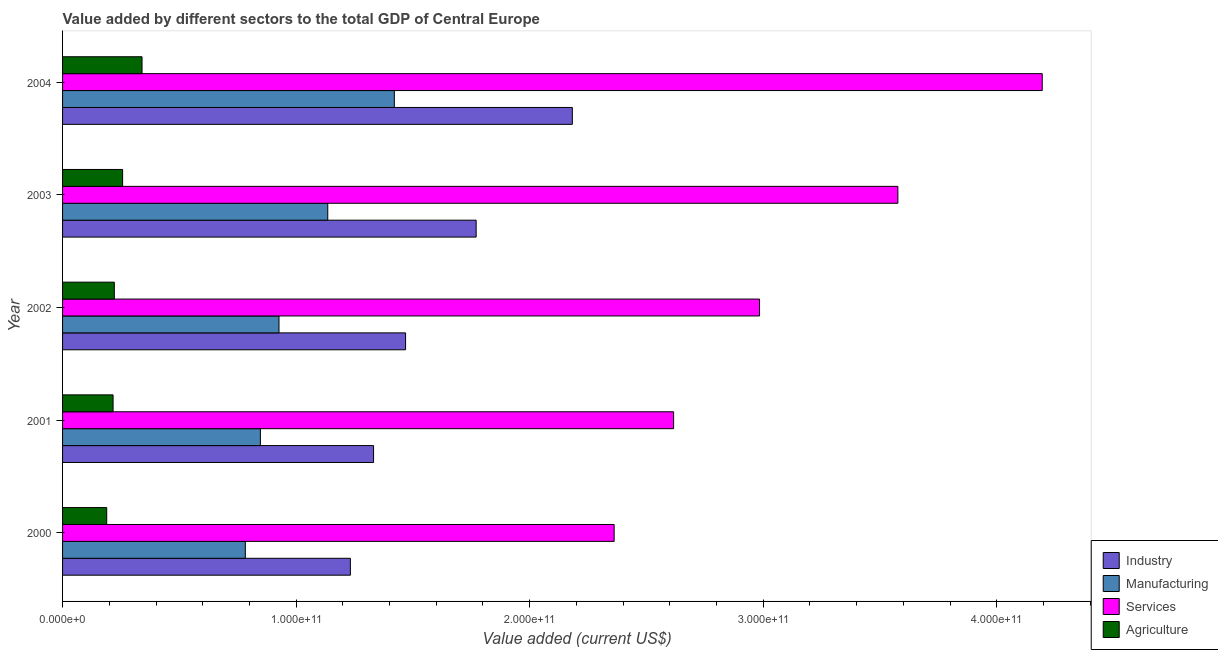How many different coloured bars are there?
Provide a short and direct response. 4. How many groups of bars are there?
Your response must be concise. 5. Are the number of bars on each tick of the Y-axis equal?
Keep it short and to the point. Yes. How many bars are there on the 3rd tick from the top?
Make the answer very short. 4. How many bars are there on the 3rd tick from the bottom?
Provide a succinct answer. 4. What is the label of the 4th group of bars from the top?
Offer a very short reply. 2001. What is the value added by manufacturing sector in 2002?
Provide a short and direct response. 9.27e+1. Across all years, what is the maximum value added by services sector?
Your response must be concise. 4.19e+11. Across all years, what is the minimum value added by services sector?
Your answer should be compact. 2.36e+11. In which year was the value added by industrial sector maximum?
Provide a succinct answer. 2004. In which year was the value added by manufacturing sector minimum?
Give a very brief answer. 2000. What is the total value added by agricultural sector in the graph?
Offer a terse response. 1.22e+11. What is the difference between the value added by industrial sector in 2000 and that in 2002?
Offer a terse response. -2.36e+1. What is the difference between the value added by industrial sector in 2004 and the value added by agricultural sector in 2002?
Your answer should be very brief. 1.96e+11. What is the average value added by services sector per year?
Offer a very short reply. 3.15e+11. In the year 2001, what is the difference between the value added by industrial sector and value added by agricultural sector?
Give a very brief answer. 1.12e+11. What is the ratio of the value added by agricultural sector in 2000 to that in 2001?
Offer a very short reply. 0.87. Is the difference between the value added by services sector in 2003 and 2004 greater than the difference between the value added by industrial sector in 2003 and 2004?
Offer a very short reply. No. What is the difference between the highest and the second highest value added by services sector?
Your response must be concise. 6.18e+1. What is the difference between the highest and the lowest value added by services sector?
Give a very brief answer. 1.83e+11. In how many years, is the value added by agricultural sector greater than the average value added by agricultural sector taken over all years?
Your answer should be compact. 2. Is it the case that in every year, the sum of the value added by agricultural sector and value added by services sector is greater than the sum of value added by industrial sector and value added by manufacturing sector?
Your answer should be very brief. No. What does the 1st bar from the top in 2002 represents?
Offer a very short reply. Agriculture. What does the 4th bar from the bottom in 2002 represents?
Make the answer very short. Agriculture. Is it the case that in every year, the sum of the value added by industrial sector and value added by manufacturing sector is greater than the value added by services sector?
Keep it short and to the point. No. How many bars are there?
Offer a terse response. 20. Are all the bars in the graph horizontal?
Your answer should be very brief. Yes. How many years are there in the graph?
Ensure brevity in your answer.  5. What is the difference between two consecutive major ticks on the X-axis?
Provide a short and direct response. 1.00e+11. Are the values on the major ticks of X-axis written in scientific E-notation?
Offer a terse response. Yes. Where does the legend appear in the graph?
Your answer should be very brief. Bottom right. How many legend labels are there?
Ensure brevity in your answer.  4. How are the legend labels stacked?
Offer a terse response. Vertical. What is the title of the graph?
Offer a terse response. Value added by different sectors to the total GDP of Central Europe. Does "Miscellaneous expenses" appear as one of the legend labels in the graph?
Ensure brevity in your answer.  No. What is the label or title of the X-axis?
Your response must be concise. Value added (current US$). What is the label or title of the Y-axis?
Offer a very short reply. Year. What is the Value added (current US$) in Industry in 2000?
Provide a succinct answer. 1.23e+11. What is the Value added (current US$) in Manufacturing in 2000?
Your answer should be very brief. 7.82e+1. What is the Value added (current US$) in Services in 2000?
Keep it short and to the point. 2.36e+11. What is the Value added (current US$) of Agriculture in 2000?
Your answer should be very brief. 1.89e+1. What is the Value added (current US$) of Industry in 2001?
Give a very brief answer. 1.33e+11. What is the Value added (current US$) in Manufacturing in 2001?
Ensure brevity in your answer.  8.47e+1. What is the Value added (current US$) of Services in 2001?
Your answer should be compact. 2.62e+11. What is the Value added (current US$) of Agriculture in 2001?
Offer a terse response. 2.16e+1. What is the Value added (current US$) in Industry in 2002?
Provide a succinct answer. 1.47e+11. What is the Value added (current US$) in Manufacturing in 2002?
Keep it short and to the point. 9.27e+1. What is the Value added (current US$) in Services in 2002?
Your answer should be very brief. 2.98e+11. What is the Value added (current US$) of Agriculture in 2002?
Your response must be concise. 2.22e+1. What is the Value added (current US$) in Industry in 2003?
Your answer should be compact. 1.77e+11. What is the Value added (current US$) of Manufacturing in 2003?
Keep it short and to the point. 1.14e+11. What is the Value added (current US$) in Services in 2003?
Keep it short and to the point. 3.58e+11. What is the Value added (current US$) of Agriculture in 2003?
Your answer should be compact. 2.57e+1. What is the Value added (current US$) in Industry in 2004?
Give a very brief answer. 2.18e+11. What is the Value added (current US$) in Manufacturing in 2004?
Your response must be concise. 1.42e+11. What is the Value added (current US$) of Services in 2004?
Provide a short and direct response. 4.19e+11. What is the Value added (current US$) of Agriculture in 2004?
Provide a short and direct response. 3.40e+1. Across all years, what is the maximum Value added (current US$) in Industry?
Ensure brevity in your answer.  2.18e+11. Across all years, what is the maximum Value added (current US$) in Manufacturing?
Keep it short and to the point. 1.42e+11. Across all years, what is the maximum Value added (current US$) in Services?
Your answer should be compact. 4.19e+11. Across all years, what is the maximum Value added (current US$) in Agriculture?
Give a very brief answer. 3.40e+1. Across all years, what is the minimum Value added (current US$) of Industry?
Ensure brevity in your answer.  1.23e+11. Across all years, what is the minimum Value added (current US$) of Manufacturing?
Ensure brevity in your answer.  7.82e+1. Across all years, what is the minimum Value added (current US$) in Services?
Ensure brevity in your answer.  2.36e+11. Across all years, what is the minimum Value added (current US$) in Agriculture?
Make the answer very short. 1.89e+1. What is the total Value added (current US$) in Industry in the graph?
Offer a terse response. 7.99e+11. What is the total Value added (current US$) in Manufacturing in the graph?
Ensure brevity in your answer.  5.11e+11. What is the total Value added (current US$) of Services in the graph?
Make the answer very short. 1.57e+12. What is the total Value added (current US$) of Agriculture in the graph?
Give a very brief answer. 1.22e+11. What is the difference between the Value added (current US$) of Industry in 2000 and that in 2001?
Your answer should be very brief. -9.93e+09. What is the difference between the Value added (current US$) in Manufacturing in 2000 and that in 2001?
Make the answer very short. -6.45e+09. What is the difference between the Value added (current US$) of Services in 2000 and that in 2001?
Your response must be concise. -2.55e+1. What is the difference between the Value added (current US$) of Agriculture in 2000 and that in 2001?
Make the answer very short. -2.73e+09. What is the difference between the Value added (current US$) of Industry in 2000 and that in 2002?
Your response must be concise. -2.36e+1. What is the difference between the Value added (current US$) in Manufacturing in 2000 and that in 2002?
Your response must be concise. -1.44e+1. What is the difference between the Value added (current US$) of Services in 2000 and that in 2002?
Ensure brevity in your answer.  -6.22e+1. What is the difference between the Value added (current US$) of Agriculture in 2000 and that in 2002?
Your response must be concise. -3.26e+09. What is the difference between the Value added (current US$) of Industry in 2000 and that in 2003?
Keep it short and to the point. -5.39e+1. What is the difference between the Value added (current US$) in Manufacturing in 2000 and that in 2003?
Your answer should be very brief. -3.53e+1. What is the difference between the Value added (current US$) in Services in 2000 and that in 2003?
Give a very brief answer. -1.21e+11. What is the difference between the Value added (current US$) of Agriculture in 2000 and that in 2003?
Your response must be concise. -6.80e+09. What is the difference between the Value added (current US$) in Industry in 2000 and that in 2004?
Your answer should be very brief. -9.50e+1. What is the difference between the Value added (current US$) in Manufacturing in 2000 and that in 2004?
Ensure brevity in your answer.  -6.38e+1. What is the difference between the Value added (current US$) in Services in 2000 and that in 2004?
Offer a very short reply. -1.83e+11. What is the difference between the Value added (current US$) in Agriculture in 2000 and that in 2004?
Your answer should be compact. -1.51e+1. What is the difference between the Value added (current US$) in Industry in 2001 and that in 2002?
Your answer should be compact. -1.37e+1. What is the difference between the Value added (current US$) of Manufacturing in 2001 and that in 2002?
Offer a very short reply. -7.97e+09. What is the difference between the Value added (current US$) of Services in 2001 and that in 2002?
Provide a short and direct response. -3.68e+1. What is the difference between the Value added (current US$) in Agriculture in 2001 and that in 2002?
Offer a terse response. -5.33e+08. What is the difference between the Value added (current US$) of Industry in 2001 and that in 2003?
Ensure brevity in your answer.  -4.39e+1. What is the difference between the Value added (current US$) in Manufacturing in 2001 and that in 2003?
Make the answer very short. -2.88e+1. What is the difference between the Value added (current US$) in Services in 2001 and that in 2003?
Offer a very short reply. -9.60e+1. What is the difference between the Value added (current US$) of Agriculture in 2001 and that in 2003?
Offer a very short reply. -4.08e+09. What is the difference between the Value added (current US$) in Industry in 2001 and that in 2004?
Give a very brief answer. -8.51e+1. What is the difference between the Value added (current US$) of Manufacturing in 2001 and that in 2004?
Give a very brief answer. -5.73e+1. What is the difference between the Value added (current US$) in Services in 2001 and that in 2004?
Your answer should be compact. -1.58e+11. What is the difference between the Value added (current US$) of Agriculture in 2001 and that in 2004?
Make the answer very short. -1.24e+1. What is the difference between the Value added (current US$) in Industry in 2002 and that in 2003?
Make the answer very short. -3.02e+1. What is the difference between the Value added (current US$) of Manufacturing in 2002 and that in 2003?
Your answer should be compact. -2.09e+1. What is the difference between the Value added (current US$) in Services in 2002 and that in 2003?
Keep it short and to the point. -5.92e+1. What is the difference between the Value added (current US$) of Agriculture in 2002 and that in 2003?
Offer a terse response. -3.54e+09. What is the difference between the Value added (current US$) of Industry in 2002 and that in 2004?
Make the answer very short. -7.14e+1. What is the difference between the Value added (current US$) in Manufacturing in 2002 and that in 2004?
Offer a very short reply. -4.94e+1. What is the difference between the Value added (current US$) of Services in 2002 and that in 2004?
Provide a succinct answer. -1.21e+11. What is the difference between the Value added (current US$) of Agriculture in 2002 and that in 2004?
Keep it short and to the point. -1.19e+1. What is the difference between the Value added (current US$) in Industry in 2003 and that in 2004?
Keep it short and to the point. -4.12e+1. What is the difference between the Value added (current US$) of Manufacturing in 2003 and that in 2004?
Make the answer very short. -2.85e+1. What is the difference between the Value added (current US$) of Services in 2003 and that in 2004?
Your response must be concise. -6.18e+1. What is the difference between the Value added (current US$) of Agriculture in 2003 and that in 2004?
Give a very brief answer. -8.32e+09. What is the difference between the Value added (current US$) in Industry in 2000 and the Value added (current US$) in Manufacturing in 2001?
Keep it short and to the point. 3.85e+1. What is the difference between the Value added (current US$) in Industry in 2000 and the Value added (current US$) in Services in 2001?
Give a very brief answer. -1.38e+11. What is the difference between the Value added (current US$) in Industry in 2000 and the Value added (current US$) in Agriculture in 2001?
Your response must be concise. 1.02e+11. What is the difference between the Value added (current US$) in Manufacturing in 2000 and the Value added (current US$) in Services in 2001?
Give a very brief answer. -1.83e+11. What is the difference between the Value added (current US$) in Manufacturing in 2000 and the Value added (current US$) in Agriculture in 2001?
Offer a terse response. 5.66e+1. What is the difference between the Value added (current US$) in Services in 2000 and the Value added (current US$) in Agriculture in 2001?
Make the answer very short. 2.15e+11. What is the difference between the Value added (current US$) of Industry in 2000 and the Value added (current US$) of Manufacturing in 2002?
Your answer should be compact. 3.06e+1. What is the difference between the Value added (current US$) of Industry in 2000 and the Value added (current US$) of Services in 2002?
Your response must be concise. -1.75e+11. What is the difference between the Value added (current US$) in Industry in 2000 and the Value added (current US$) in Agriculture in 2002?
Provide a short and direct response. 1.01e+11. What is the difference between the Value added (current US$) in Manufacturing in 2000 and the Value added (current US$) in Services in 2002?
Provide a succinct answer. -2.20e+11. What is the difference between the Value added (current US$) in Manufacturing in 2000 and the Value added (current US$) in Agriculture in 2002?
Your answer should be compact. 5.61e+1. What is the difference between the Value added (current US$) in Services in 2000 and the Value added (current US$) in Agriculture in 2002?
Your answer should be compact. 2.14e+11. What is the difference between the Value added (current US$) of Industry in 2000 and the Value added (current US$) of Manufacturing in 2003?
Keep it short and to the point. 9.68e+09. What is the difference between the Value added (current US$) in Industry in 2000 and the Value added (current US$) in Services in 2003?
Provide a short and direct response. -2.34e+11. What is the difference between the Value added (current US$) of Industry in 2000 and the Value added (current US$) of Agriculture in 2003?
Offer a very short reply. 9.75e+1. What is the difference between the Value added (current US$) of Manufacturing in 2000 and the Value added (current US$) of Services in 2003?
Your answer should be compact. -2.79e+11. What is the difference between the Value added (current US$) of Manufacturing in 2000 and the Value added (current US$) of Agriculture in 2003?
Your answer should be compact. 5.25e+1. What is the difference between the Value added (current US$) in Services in 2000 and the Value added (current US$) in Agriculture in 2003?
Provide a short and direct response. 2.10e+11. What is the difference between the Value added (current US$) in Industry in 2000 and the Value added (current US$) in Manufacturing in 2004?
Make the answer very short. -1.88e+1. What is the difference between the Value added (current US$) in Industry in 2000 and the Value added (current US$) in Services in 2004?
Keep it short and to the point. -2.96e+11. What is the difference between the Value added (current US$) of Industry in 2000 and the Value added (current US$) of Agriculture in 2004?
Your answer should be very brief. 8.92e+1. What is the difference between the Value added (current US$) in Manufacturing in 2000 and the Value added (current US$) in Services in 2004?
Your answer should be compact. -3.41e+11. What is the difference between the Value added (current US$) in Manufacturing in 2000 and the Value added (current US$) in Agriculture in 2004?
Give a very brief answer. 4.42e+1. What is the difference between the Value added (current US$) in Services in 2000 and the Value added (current US$) in Agriculture in 2004?
Ensure brevity in your answer.  2.02e+11. What is the difference between the Value added (current US$) of Industry in 2001 and the Value added (current US$) of Manufacturing in 2002?
Keep it short and to the point. 4.05e+1. What is the difference between the Value added (current US$) of Industry in 2001 and the Value added (current US$) of Services in 2002?
Offer a terse response. -1.65e+11. What is the difference between the Value added (current US$) in Industry in 2001 and the Value added (current US$) in Agriculture in 2002?
Provide a succinct answer. 1.11e+11. What is the difference between the Value added (current US$) of Manufacturing in 2001 and the Value added (current US$) of Services in 2002?
Offer a very short reply. -2.14e+11. What is the difference between the Value added (current US$) of Manufacturing in 2001 and the Value added (current US$) of Agriculture in 2002?
Ensure brevity in your answer.  6.25e+1. What is the difference between the Value added (current US$) of Services in 2001 and the Value added (current US$) of Agriculture in 2002?
Keep it short and to the point. 2.39e+11. What is the difference between the Value added (current US$) of Industry in 2001 and the Value added (current US$) of Manufacturing in 2003?
Provide a short and direct response. 1.96e+1. What is the difference between the Value added (current US$) of Industry in 2001 and the Value added (current US$) of Services in 2003?
Offer a very short reply. -2.24e+11. What is the difference between the Value added (current US$) of Industry in 2001 and the Value added (current US$) of Agriculture in 2003?
Offer a terse response. 1.07e+11. What is the difference between the Value added (current US$) of Manufacturing in 2001 and the Value added (current US$) of Services in 2003?
Provide a succinct answer. -2.73e+11. What is the difference between the Value added (current US$) of Manufacturing in 2001 and the Value added (current US$) of Agriculture in 2003?
Ensure brevity in your answer.  5.90e+1. What is the difference between the Value added (current US$) of Services in 2001 and the Value added (current US$) of Agriculture in 2003?
Your answer should be very brief. 2.36e+11. What is the difference between the Value added (current US$) of Industry in 2001 and the Value added (current US$) of Manufacturing in 2004?
Keep it short and to the point. -8.89e+09. What is the difference between the Value added (current US$) of Industry in 2001 and the Value added (current US$) of Services in 2004?
Offer a terse response. -2.86e+11. What is the difference between the Value added (current US$) of Industry in 2001 and the Value added (current US$) of Agriculture in 2004?
Your answer should be compact. 9.91e+1. What is the difference between the Value added (current US$) of Manufacturing in 2001 and the Value added (current US$) of Services in 2004?
Make the answer very short. -3.35e+11. What is the difference between the Value added (current US$) in Manufacturing in 2001 and the Value added (current US$) in Agriculture in 2004?
Provide a succinct answer. 5.07e+1. What is the difference between the Value added (current US$) of Services in 2001 and the Value added (current US$) of Agriculture in 2004?
Offer a terse response. 2.28e+11. What is the difference between the Value added (current US$) of Industry in 2002 and the Value added (current US$) of Manufacturing in 2003?
Your answer should be very brief. 3.33e+1. What is the difference between the Value added (current US$) in Industry in 2002 and the Value added (current US$) in Services in 2003?
Your answer should be very brief. -2.11e+11. What is the difference between the Value added (current US$) of Industry in 2002 and the Value added (current US$) of Agriculture in 2003?
Offer a terse response. 1.21e+11. What is the difference between the Value added (current US$) of Manufacturing in 2002 and the Value added (current US$) of Services in 2003?
Your answer should be compact. -2.65e+11. What is the difference between the Value added (current US$) of Manufacturing in 2002 and the Value added (current US$) of Agriculture in 2003?
Your response must be concise. 6.70e+1. What is the difference between the Value added (current US$) of Services in 2002 and the Value added (current US$) of Agriculture in 2003?
Make the answer very short. 2.73e+11. What is the difference between the Value added (current US$) in Industry in 2002 and the Value added (current US$) in Manufacturing in 2004?
Keep it short and to the point. 4.81e+09. What is the difference between the Value added (current US$) in Industry in 2002 and the Value added (current US$) in Services in 2004?
Provide a short and direct response. -2.73e+11. What is the difference between the Value added (current US$) in Industry in 2002 and the Value added (current US$) in Agriculture in 2004?
Offer a very short reply. 1.13e+11. What is the difference between the Value added (current US$) in Manufacturing in 2002 and the Value added (current US$) in Services in 2004?
Your answer should be compact. -3.27e+11. What is the difference between the Value added (current US$) in Manufacturing in 2002 and the Value added (current US$) in Agriculture in 2004?
Your answer should be compact. 5.86e+1. What is the difference between the Value added (current US$) of Services in 2002 and the Value added (current US$) of Agriculture in 2004?
Make the answer very short. 2.64e+11. What is the difference between the Value added (current US$) of Industry in 2003 and the Value added (current US$) of Manufacturing in 2004?
Your answer should be compact. 3.50e+1. What is the difference between the Value added (current US$) in Industry in 2003 and the Value added (current US$) in Services in 2004?
Offer a very short reply. -2.42e+11. What is the difference between the Value added (current US$) of Industry in 2003 and the Value added (current US$) of Agriculture in 2004?
Your response must be concise. 1.43e+11. What is the difference between the Value added (current US$) of Manufacturing in 2003 and the Value added (current US$) of Services in 2004?
Offer a very short reply. -3.06e+11. What is the difference between the Value added (current US$) of Manufacturing in 2003 and the Value added (current US$) of Agriculture in 2004?
Provide a succinct answer. 7.95e+1. What is the difference between the Value added (current US$) of Services in 2003 and the Value added (current US$) of Agriculture in 2004?
Keep it short and to the point. 3.24e+11. What is the average Value added (current US$) of Industry per year?
Provide a short and direct response. 1.60e+11. What is the average Value added (current US$) in Manufacturing per year?
Your answer should be compact. 1.02e+11. What is the average Value added (current US$) in Services per year?
Your answer should be compact. 3.15e+11. What is the average Value added (current US$) of Agriculture per year?
Your response must be concise. 2.45e+1. In the year 2000, what is the difference between the Value added (current US$) of Industry and Value added (current US$) of Manufacturing?
Ensure brevity in your answer.  4.50e+1. In the year 2000, what is the difference between the Value added (current US$) of Industry and Value added (current US$) of Services?
Give a very brief answer. -1.13e+11. In the year 2000, what is the difference between the Value added (current US$) in Industry and Value added (current US$) in Agriculture?
Your answer should be compact. 1.04e+11. In the year 2000, what is the difference between the Value added (current US$) of Manufacturing and Value added (current US$) of Services?
Your answer should be very brief. -1.58e+11. In the year 2000, what is the difference between the Value added (current US$) in Manufacturing and Value added (current US$) in Agriculture?
Ensure brevity in your answer.  5.93e+1. In the year 2000, what is the difference between the Value added (current US$) of Services and Value added (current US$) of Agriculture?
Give a very brief answer. 2.17e+11. In the year 2001, what is the difference between the Value added (current US$) in Industry and Value added (current US$) in Manufacturing?
Provide a succinct answer. 4.85e+1. In the year 2001, what is the difference between the Value added (current US$) of Industry and Value added (current US$) of Services?
Your answer should be very brief. -1.28e+11. In the year 2001, what is the difference between the Value added (current US$) in Industry and Value added (current US$) in Agriculture?
Ensure brevity in your answer.  1.12e+11. In the year 2001, what is the difference between the Value added (current US$) in Manufacturing and Value added (current US$) in Services?
Keep it short and to the point. -1.77e+11. In the year 2001, what is the difference between the Value added (current US$) in Manufacturing and Value added (current US$) in Agriculture?
Give a very brief answer. 6.31e+1. In the year 2001, what is the difference between the Value added (current US$) of Services and Value added (current US$) of Agriculture?
Ensure brevity in your answer.  2.40e+11. In the year 2002, what is the difference between the Value added (current US$) of Industry and Value added (current US$) of Manufacturing?
Your response must be concise. 5.42e+1. In the year 2002, what is the difference between the Value added (current US$) in Industry and Value added (current US$) in Services?
Offer a terse response. -1.52e+11. In the year 2002, what is the difference between the Value added (current US$) in Industry and Value added (current US$) in Agriculture?
Offer a very short reply. 1.25e+11. In the year 2002, what is the difference between the Value added (current US$) in Manufacturing and Value added (current US$) in Services?
Offer a very short reply. -2.06e+11. In the year 2002, what is the difference between the Value added (current US$) in Manufacturing and Value added (current US$) in Agriculture?
Provide a short and direct response. 7.05e+1. In the year 2002, what is the difference between the Value added (current US$) in Services and Value added (current US$) in Agriculture?
Your response must be concise. 2.76e+11. In the year 2003, what is the difference between the Value added (current US$) of Industry and Value added (current US$) of Manufacturing?
Provide a succinct answer. 6.35e+1. In the year 2003, what is the difference between the Value added (current US$) in Industry and Value added (current US$) in Services?
Your answer should be compact. -1.81e+11. In the year 2003, what is the difference between the Value added (current US$) of Industry and Value added (current US$) of Agriculture?
Provide a succinct answer. 1.51e+11. In the year 2003, what is the difference between the Value added (current US$) of Manufacturing and Value added (current US$) of Services?
Your answer should be very brief. -2.44e+11. In the year 2003, what is the difference between the Value added (current US$) in Manufacturing and Value added (current US$) in Agriculture?
Keep it short and to the point. 8.78e+1. In the year 2003, what is the difference between the Value added (current US$) in Services and Value added (current US$) in Agriculture?
Keep it short and to the point. 3.32e+11. In the year 2004, what is the difference between the Value added (current US$) of Industry and Value added (current US$) of Manufacturing?
Offer a very short reply. 7.62e+1. In the year 2004, what is the difference between the Value added (current US$) of Industry and Value added (current US$) of Services?
Offer a very short reply. -2.01e+11. In the year 2004, what is the difference between the Value added (current US$) of Industry and Value added (current US$) of Agriculture?
Ensure brevity in your answer.  1.84e+11. In the year 2004, what is the difference between the Value added (current US$) of Manufacturing and Value added (current US$) of Services?
Your answer should be compact. -2.77e+11. In the year 2004, what is the difference between the Value added (current US$) of Manufacturing and Value added (current US$) of Agriculture?
Make the answer very short. 1.08e+11. In the year 2004, what is the difference between the Value added (current US$) in Services and Value added (current US$) in Agriculture?
Give a very brief answer. 3.85e+11. What is the ratio of the Value added (current US$) in Industry in 2000 to that in 2001?
Provide a succinct answer. 0.93. What is the ratio of the Value added (current US$) of Manufacturing in 2000 to that in 2001?
Your answer should be very brief. 0.92. What is the ratio of the Value added (current US$) of Services in 2000 to that in 2001?
Your answer should be very brief. 0.9. What is the ratio of the Value added (current US$) of Agriculture in 2000 to that in 2001?
Provide a succinct answer. 0.87. What is the ratio of the Value added (current US$) in Industry in 2000 to that in 2002?
Your response must be concise. 0.84. What is the ratio of the Value added (current US$) in Manufacturing in 2000 to that in 2002?
Your answer should be very brief. 0.84. What is the ratio of the Value added (current US$) in Services in 2000 to that in 2002?
Provide a short and direct response. 0.79. What is the ratio of the Value added (current US$) of Agriculture in 2000 to that in 2002?
Your answer should be very brief. 0.85. What is the ratio of the Value added (current US$) in Industry in 2000 to that in 2003?
Offer a very short reply. 0.7. What is the ratio of the Value added (current US$) in Manufacturing in 2000 to that in 2003?
Offer a terse response. 0.69. What is the ratio of the Value added (current US$) in Services in 2000 to that in 2003?
Offer a very short reply. 0.66. What is the ratio of the Value added (current US$) in Agriculture in 2000 to that in 2003?
Make the answer very short. 0.74. What is the ratio of the Value added (current US$) in Industry in 2000 to that in 2004?
Offer a very short reply. 0.56. What is the ratio of the Value added (current US$) in Manufacturing in 2000 to that in 2004?
Keep it short and to the point. 0.55. What is the ratio of the Value added (current US$) in Services in 2000 to that in 2004?
Make the answer very short. 0.56. What is the ratio of the Value added (current US$) of Agriculture in 2000 to that in 2004?
Provide a short and direct response. 0.56. What is the ratio of the Value added (current US$) in Industry in 2001 to that in 2002?
Provide a succinct answer. 0.91. What is the ratio of the Value added (current US$) of Manufacturing in 2001 to that in 2002?
Ensure brevity in your answer.  0.91. What is the ratio of the Value added (current US$) in Services in 2001 to that in 2002?
Provide a succinct answer. 0.88. What is the ratio of the Value added (current US$) in Agriculture in 2001 to that in 2002?
Provide a short and direct response. 0.98. What is the ratio of the Value added (current US$) of Industry in 2001 to that in 2003?
Your answer should be compact. 0.75. What is the ratio of the Value added (current US$) of Manufacturing in 2001 to that in 2003?
Make the answer very short. 0.75. What is the ratio of the Value added (current US$) in Services in 2001 to that in 2003?
Make the answer very short. 0.73. What is the ratio of the Value added (current US$) of Agriculture in 2001 to that in 2003?
Offer a terse response. 0.84. What is the ratio of the Value added (current US$) in Industry in 2001 to that in 2004?
Your answer should be compact. 0.61. What is the ratio of the Value added (current US$) of Manufacturing in 2001 to that in 2004?
Keep it short and to the point. 0.6. What is the ratio of the Value added (current US$) in Services in 2001 to that in 2004?
Your answer should be compact. 0.62. What is the ratio of the Value added (current US$) in Agriculture in 2001 to that in 2004?
Offer a very short reply. 0.64. What is the ratio of the Value added (current US$) of Industry in 2002 to that in 2003?
Offer a very short reply. 0.83. What is the ratio of the Value added (current US$) of Manufacturing in 2002 to that in 2003?
Offer a terse response. 0.82. What is the ratio of the Value added (current US$) in Services in 2002 to that in 2003?
Offer a very short reply. 0.83. What is the ratio of the Value added (current US$) in Agriculture in 2002 to that in 2003?
Give a very brief answer. 0.86. What is the ratio of the Value added (current US$) in Industry in 2002 to that in 2004?
Your answer should be very brief. 0.67. What is the ratio of the Value added (current US$) in Manufacturing in 2002 to that in 2004?
Offer a terse response. 0.65. What is the ratio of the Value added (current US$) in Services in 2002 to that in 2004?
Keep it short and to the point. 0.71. What is the ratio of the Value added (current US$) of Agriculture in 2002 to that in 2004?
Ensure brevity in your answer.  0.65. What is the ratio of the Value added (current US$) in Industry in 2003 to that in 2004?
Provide a succinct answer. 0.81. What is the ratio of the Value added (current US$) in Manufacturing in 2003 to that in 2004?
Offer a very short reply. 0.8. What is the ratio of the Value added (current US$) in Services in 2003 to that in 2004?
Offer a very short reply. 0.85. What is the ratio of the Value added (current US$) of Agriculture in 2003 to that in 2004?
Your response must be concise. 0.76. What is the difference between the highest and the second highest Value added (current US$) of Industry?
Offer a terse response. 4.12e+1. What is the difference between the highest and the second highest Value added (current US$) of Manufacturing?
Provide a succinct answer. 2.85e+1. What is the difference between the highest and the second highest Value added (current US$) in Services?
Give a very brief answer. 6.18e+1. What is the difference between the highest and the second highest Value added (current US$) in Agriculture?
Provide a succinct answer. 8.32e+09. What is the difference between the highest and the lowest Value added (current US$) of Industry?
Keep it short and to the point. 9.50e+1. What is the difference between the highest and the lowest Value added (current US$) of Manufacturing?
Offer a terse response. 6.38e+1. What is the difference between the highest and the lowest Value added (current US$) in Services?
Make the answer very short. 1.83e+11. What is the difference between the highest and the lowest Value added (current US$) in Agriculture?
Provide a succinct answer. 1.51e+1. 